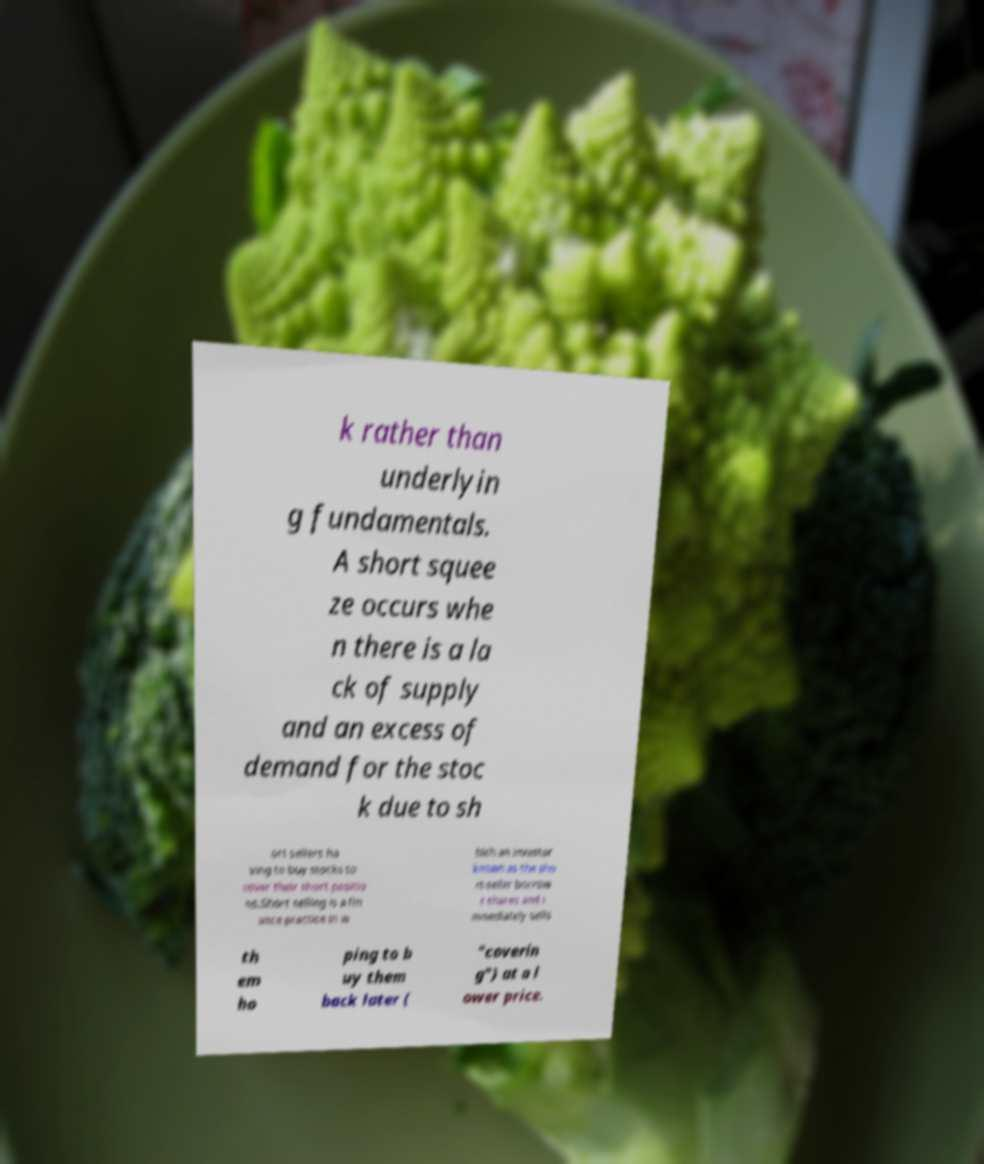There's text embedded in this image that I need extracted. Can you transcribe it verbatim? k rather than underlyin g fundamentals. A short squee ze occurs whe n there is a la ck of supply and an excess of demand for the stoc k due to sh ort sellers ha ving to buy stocks to cover their short positio ns.Short selling is a fin ance practice in w hich an investor known as the sho rt-seller borrow s shares and i mmediately sells th em ho ping to b uy them back later ( "coverin g") at a l ower price. 